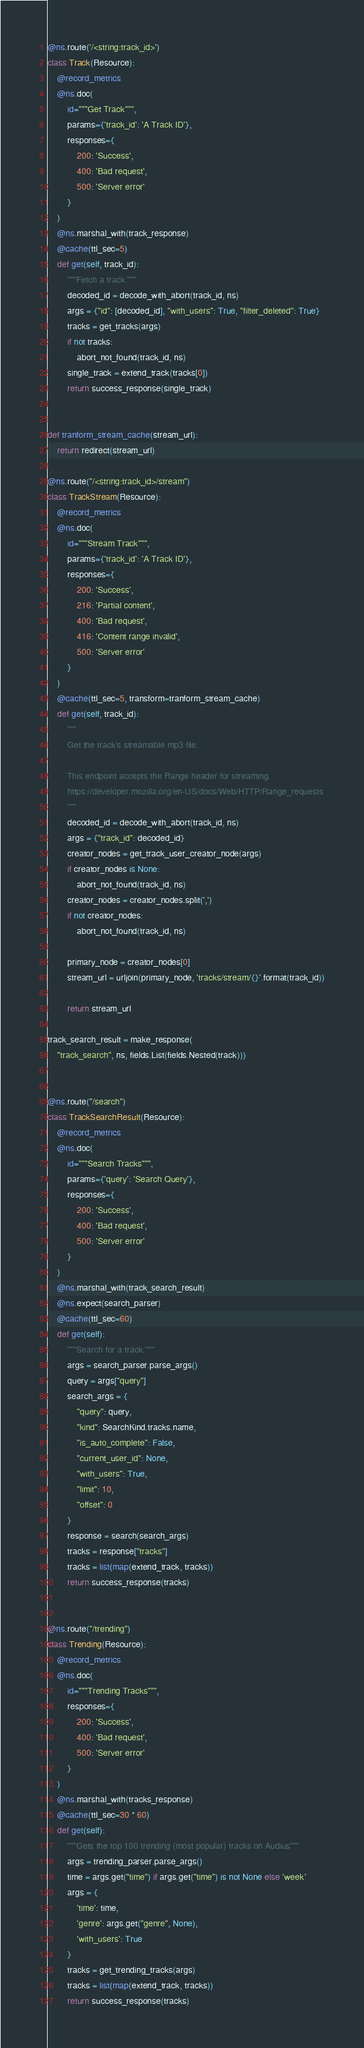Convert code to text. <code><loc_0><loc_0><loc_500><loc_500><_Python_>
@ns.route('/<string:track_id>')
class Track(Resource):
    @record_metrics
    @ns.doc(
        id="""Get Track""",
        params={'track_id': 'A Track ID'},
        responses={
            200: 'Success',
            400: 'Bad request',
            500: 'Server error'
        }
    )
    @ns.marshal_with(track_response)
    @cache(ttl_sec=5)
    def get(self, track_id):
        """Fetch a track."""
        decoded_id = decode_with_abort(track_id, ns)
        args = {"id": [decoded_id], "with_users": True, "filter_deleted": True}
        tracks = get_tracks(args)
        if not tracks:
            abort_not_found(track_id, ns)
        single_track = extend_track(tracks[0])
        return success_response(single_track)


def tranform_stream_cache(stream_url):
    return redirect(stream_url)

@ns.route("/<string:track_id>/stream")
class TrackStream(Resource):
    @record_metrics
    @ns.doc(
        id="""Stream Track""",
        params={'track_id': 'A Track ID'},
        responses={
            200: 'Success',
            216: 'Partial content',
            400: 'Bad request',
            416: 'Content range invalid',
            500: 'Server error'
        }
    )
    @cache(ttl_sec=5, transform=tranform_stream_cache)
    def get(self, track_id):
        """
        Get the track's streamable mp3 file.

        This endpoint accepts the Range header for streaming.
        https://developer.mozilla.org/en-US/docs/Web/HTTP/Range_requests
        """
        decoded_id = decode_with_abort(track_id, ns)
        args = {"track_id": decoded_id}
        creator_nodes = get_track_user_creator_node(args)
        if creator_nodes is None:
            abort_not_found(track_id, ns)
        creator_nodes = creator_nodes.split(',')
        if not creator_nodes:
            abort_not_found(track_id, ns)

        primary_node = creator_nodes[0]
        stream_url = urljoin(primary_node, 'tracks/stream/{}'.format(track_id))

        return stream_url

track_search_result = make_response(
    "track_search", ns, fields.List(fields.Nested(track)))


@ns.route("/search")
class TrackSearchResult(Resource):
    @record_metrics
    @ns.doc(
        id="""Search Tracks""",
        params={'query': 'Search Query'},
        responses={
            200: 'Success',
            400: 'Bad request',
            500: 'Server error'
        }
    )
    @ns.marshal_with(track_search_result)
    @ns.expect(search_parser)
    @cache(ttl_sec=60)
    def get(self):
        """Search for a track."""
        args = search_parser.parse_args()
        query = args["query"]
        search_args = {
            "query": query,
            "kind": SearchKind.tracks.name,
            "is_auto_complete": False,
            "current_user_id": None,
            "with_users": True,
            "limit": 10,
            "offset": 0
        }
        response = search(search_args)
        tracks = response["tracks"]
        tracks = list(map(extend_track, tracks))
        return success_response(tracks)


@ns.route("/trending")
class Trending(Resource):
    @record_metrics
    @ns.doc(
        id="""Trending Tracks""",
        responses={
            200: 'Success',
            400: 'Bad request',
            500: 'Server error'
        }
    )
    @ns.marshal_with(tracks_response)
    @cache(ttl_sec=30 * 60)
    def get(self):
        """Gets the top 100 trending (most popular) tracks on Audius"""
        args = trending_parser.parse_args()
        time = args.get("time") if args.get("time") is not None else 'week'
        args = {
            'time': time,
            'genre': args.get("genre", None),
            'with_users': True
        }
        tracks = get_trending_tracks(args)
        tracks = list(map(extend_track, tracks))
        return success_response(tracks)
</code> 